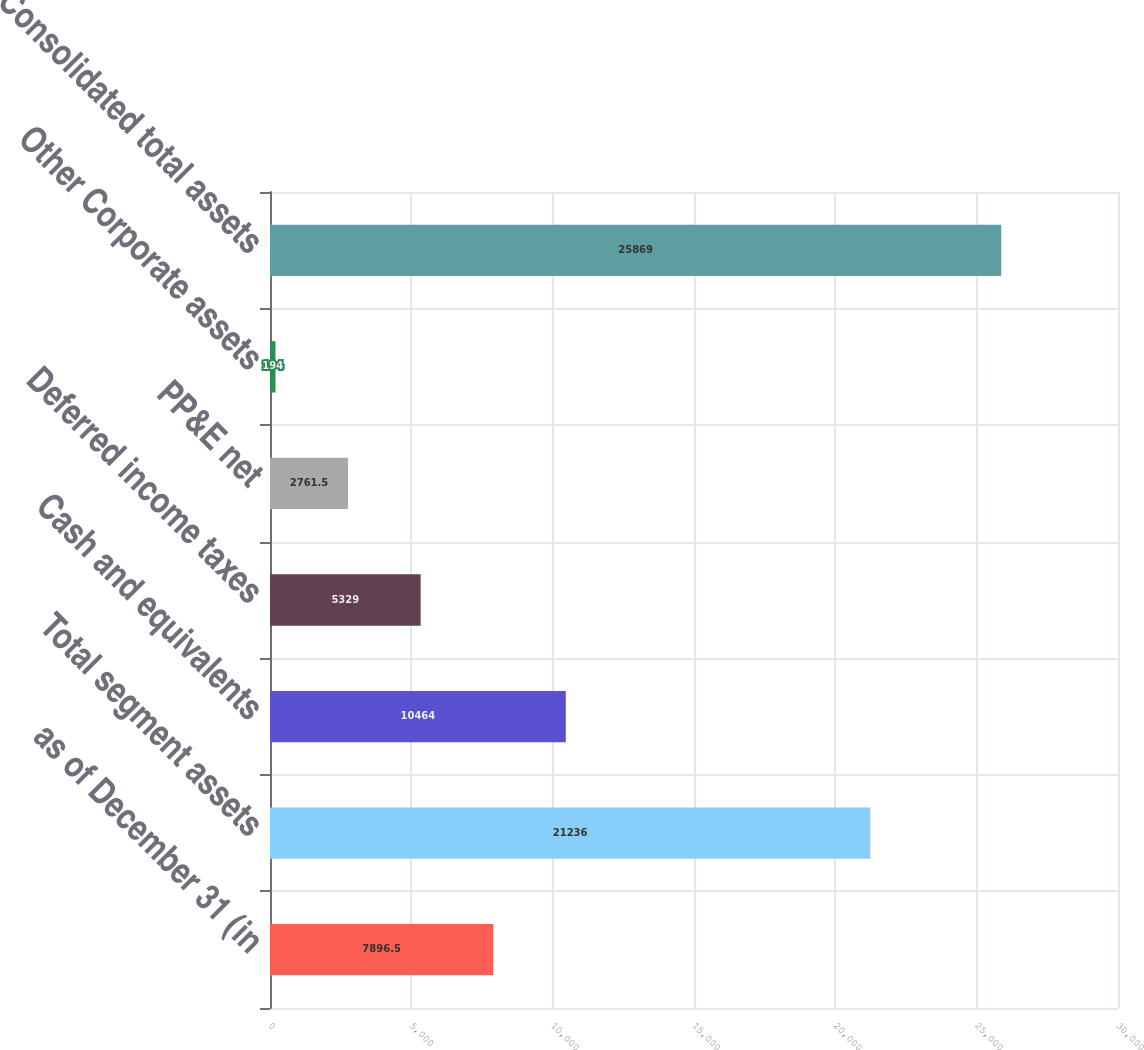Convert chart to OTSL. <chart><loc_0><loc_0><loc_500><loc_500><bar_chart><fcel>as of December 31 (in<fcel>Total segment assets<fcel>Cash and equivalents<fcel>Deferred income taxes<fcel>PP&E net<fcel>Other Corporate assets<fcel>Consolidated total assets<nl><fcel>7896.5<fcel>21236<fcel>10464<fcel>5329<fcel>2761.5<fcel>194<fcel>25869<nl></chart> 